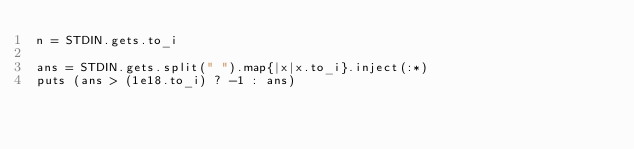<code> <loc_0><loc_0><loc_500><loc_500><_Ruby_>n = STDIN.gets.to_i

ans = STDIN.gets.split(" ").map{|x|x.to_i}.inject(:*)
puts (ans > (1e18.to_i) ? -1 : ans)
</code> 